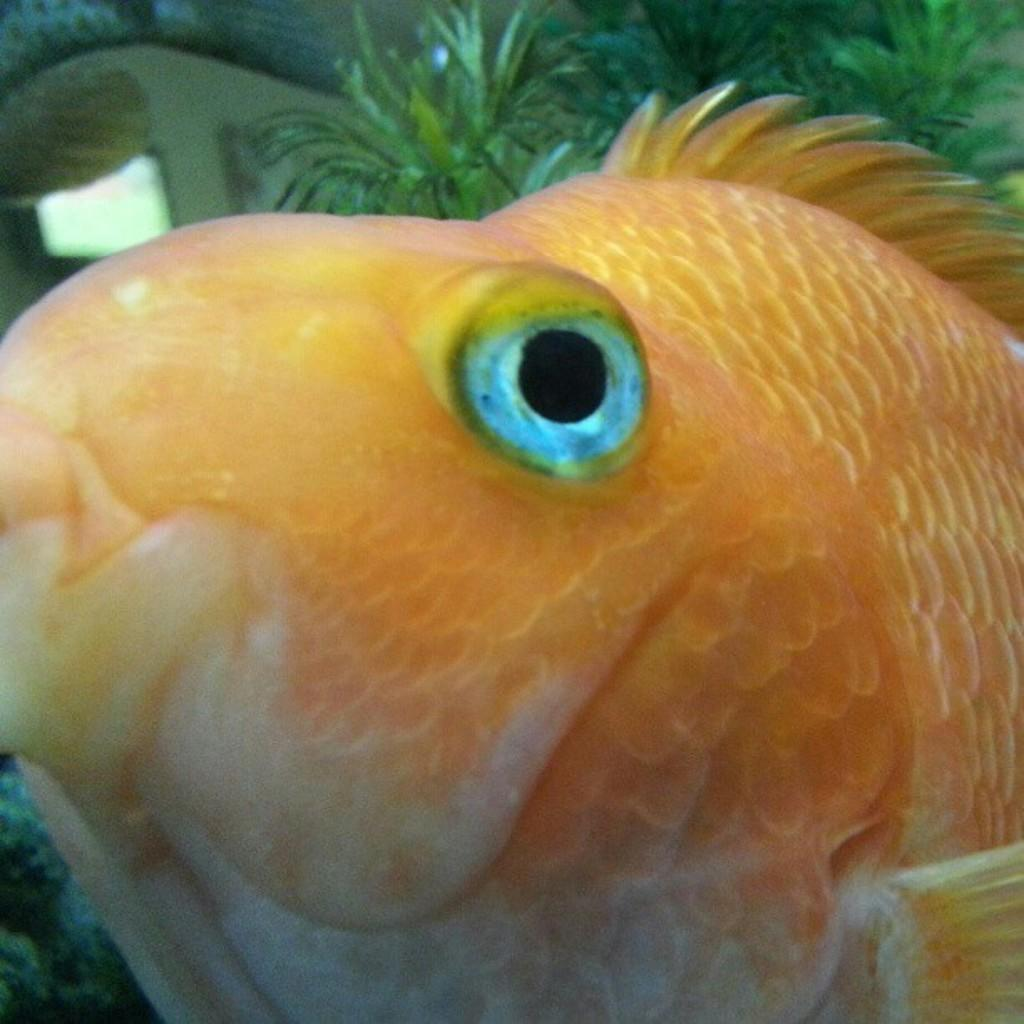What type of animal is in the image? There is a fish in the image. Can you describe the color of the fish? The fish is orange and white in color. What else can be seen in the image besides the fish? There are leaves visible in the image. What type of curtain can be seen hanging in the alley in the image? There is no alley or curtain present in the image; it features a fish and leaves. 